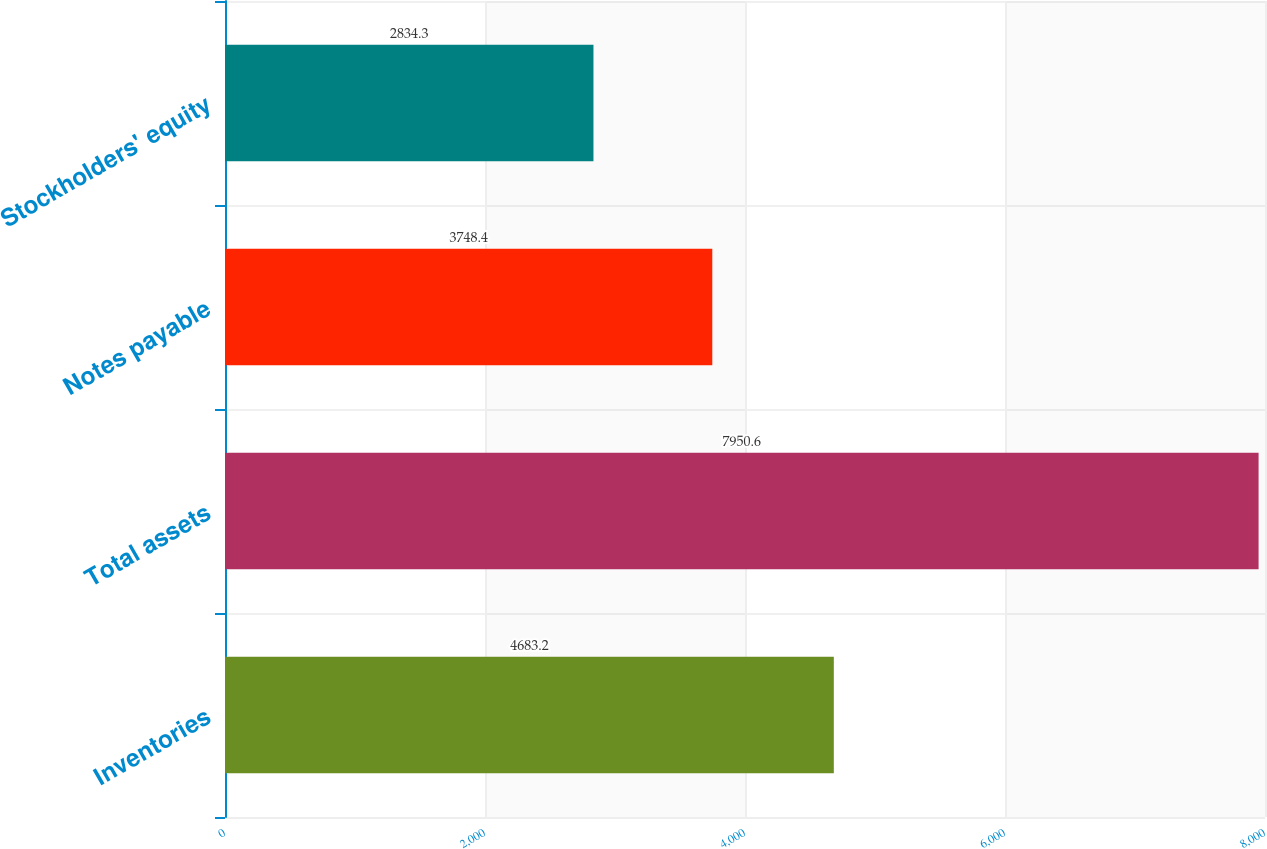Convert chart to OTSL. <chart><loc_0><loc_0><loc_500><loc_500><bar_chart><fcel>Inventories<fcel>Total assets<fcel>Notes payable<fcel>Stockholders' equity<nl><fcel>4683.2<fcel>7950.6<fcel>3748.4<fcel>2834.3<nl></chart> 